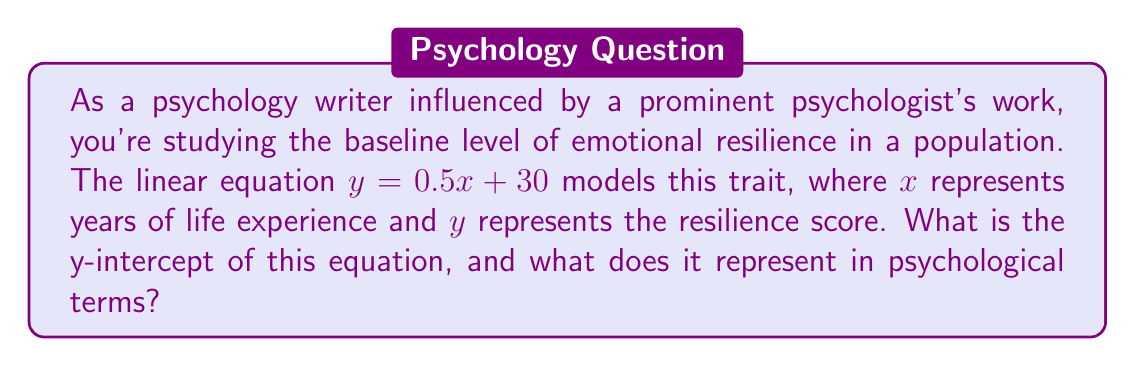Can you solve this math problem? To find the y-intercept of a linear equation, we follow these steps:

1) The general form of a linear equation is $y = mx + b$, where $b$ is the y-intercept.

2) In our equation $y = 0.5x + 30$, we can identify that:
   $m = 0.5$ (slope)
   $b = 30$ (y-intercept)

3) Therefore, the y-intercept is 30.

In psychological terms, the y-intercept represents the baseline level of emotional resilience for an individual with no life experience (x = 0 years). This could be interpreted as the innate or initial level of resilience a person has at birth or very early in life, before significant life experiences have occurred.

This concept aligns with psychological theories that suggest some traits have a baseline level that can be influenced by factors such as genetics or early environmental conditions, even before substantial life experiences accumulate.
Answer: 30; initial resilience level at birth 